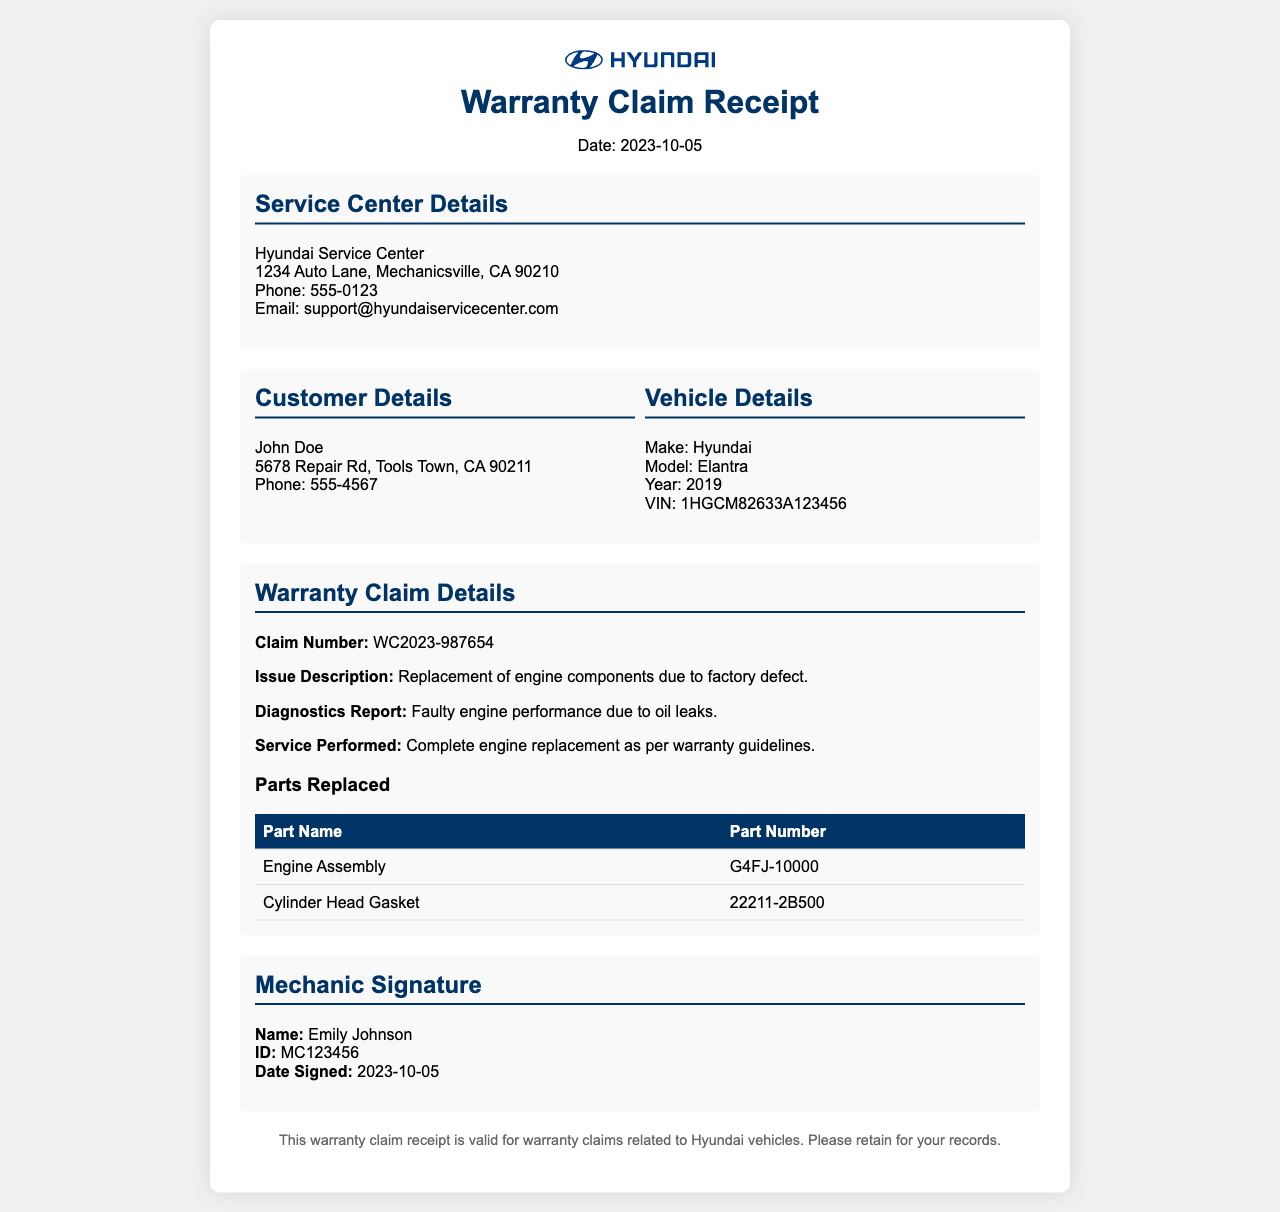What is the claim number? The claim number is explicitly mentioned in the warranty claim details section of the document.
Answer: WC2023-987654 Who is the mechanic that signed the receipt? The section contains the mechanic's name who is responsible for the service performed.
Answer: Emily Johnson What is the date of the warranty claim receipt? The date is stated at the top of the document under the header.
Answer: 2023-10-05 What vehicle model is mentioned in the document? The vehicle details section lists the model of the car.
Answer: Elantra What are the main components replaced? The parts replaced section provides a table listing the names of the parts.
Answer: Engine Assembly, Cylinder Head Gasket What is the phone number of the service center? The phone number for the service center is provided in the service center details section.
Answer: 555-0123 What is the issue description for the warranty claim? The issue description is specified in the warranty claim details and provides the nature of the problem.
Answer: Replacement of engine components due to factory defect What was the diagnosis report? The diagnostics report is presented in the warranty claim details section describing the issue.
Answer: Faulty engine performance due to oil leaks What is the part number for the Engine Assembly? The part number is listed in the table under the parts replaced section for that specific component.
Answer: G4FJ-10000 